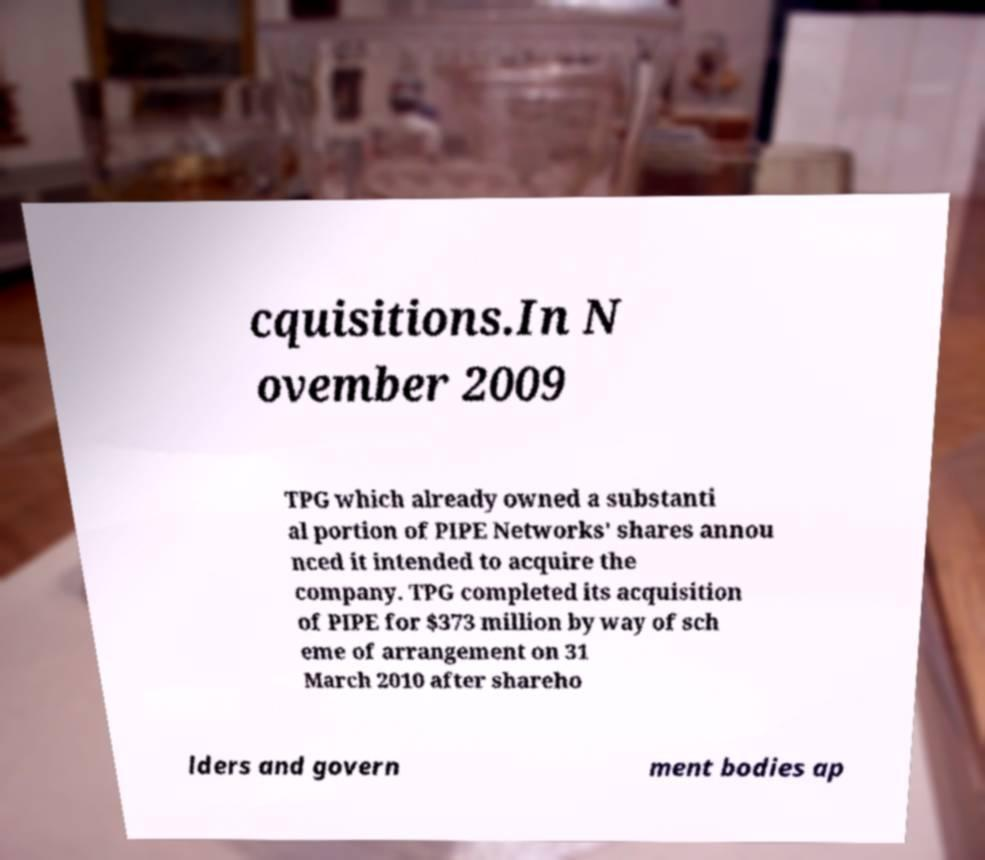Could you extract and type out the text from this image? cquisitions.In N ovember 2009 TPG which already owned a substanti al portion of PIPE Networks' shares annou nced it intended to acquire the company. TPG completed its acquisition of PIPE for $373 million by way of sch eme of arrangement on 31 March 2010 after shareho lders and govern ment bodies ap 